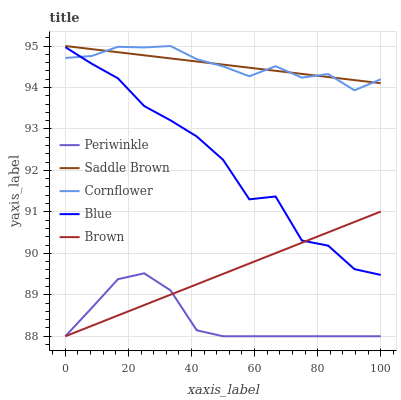Does Periwinkle have the minimum area under the curve?
Answer yes or no. Yes. Does Cornflower have the maximum area under the curve?
Answer yes or no. Yes. Does Cornflower have the minimum area under the curve?
Answer yes or no. No. Does Periwinkle have the maximum area under the curve?
Answer yes or no. No. Is Saddle Brown the smoothest?
Answer yes or no. Yes. Is Blue the roughest?
Answer yes or no. Yes. Is Cornflower the smoothest?
Answer yes or no. No. Is Cornflower the roughest?
Answer yes or no. No. Does Periwinkle have the lowest value?
Answer yes or no. Yes. Does Cornflower have the lowest value?
Answer yes or no. No. Does Saddle Brown have the highest value?
Answer yes or no. Yes. Does Periwinkle have the highest value?
Answer yes or no. No. Is Brown less than Saddle Brown?
Answer yes or no. Yes. Is Saddle Brown greater than Brown?
Answer yes or no. Yes. Does Brown intersect Periwinkle?
Answer yes or no. Yes. Is Brown less than Periwinkle?
Answer yes or no. No. Is Brown greater than Periwinkle?
Answer yes or no. No. Does Brown intersect Saddle Brown?
Answer yes or no. No. 